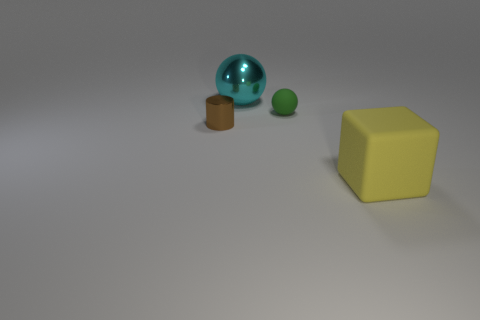What number of objects are either tiny things behind the brown shiny cylinder or tiny purple rubber cubes?
Give a very brief answer. 1. Are there fewer big matte things than big cyan rubber objects?
Provide a succinct answer. No. What is the shape of the object in front of the metal thing in front of the large thing behind the yellow matte thing?
Offer a terse response. Cube. Are any tiny purple rubber cubes visible?
Your answer should be compact. No. Is the size of the cyan shiny ball the same as the yellow block to the right of the cyan sphere?
Provide a short and direct response. Yes. Is there a big object that is in front of the object that is behind the green ball?
Offer a very short reply. Yes. There is a object that is both to the left of the tiny rubber ball and in front of the cyan metallic object; what is it made of?
Make the answer very short. Metal. There is a big object on the right side of the small thing behind the brown cylinder left of the big cyan sphere; what is its color?
Make the answer very short. Yellow. What color is the cylinder that is the same size as the green sphere?
Keep it short and to the point. Brown. There is a small shiny object; is its color the same as the tiny object that is on the right side of the big metallic ball?
Give a very brief answer. No. 